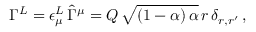<formula> <loc_0><loc_0><loc_500><loc_500>\Gamma ^ { L } = \epsilon _ { \mu } ^ { L } \, \hat { \Gamma } ^ { \mu } = Q \, \sqrt { ( 1 - \alpha ) \, \alpha } \, r \, \delta _ { r , r ^ { \prime } } \, ,</formula> 